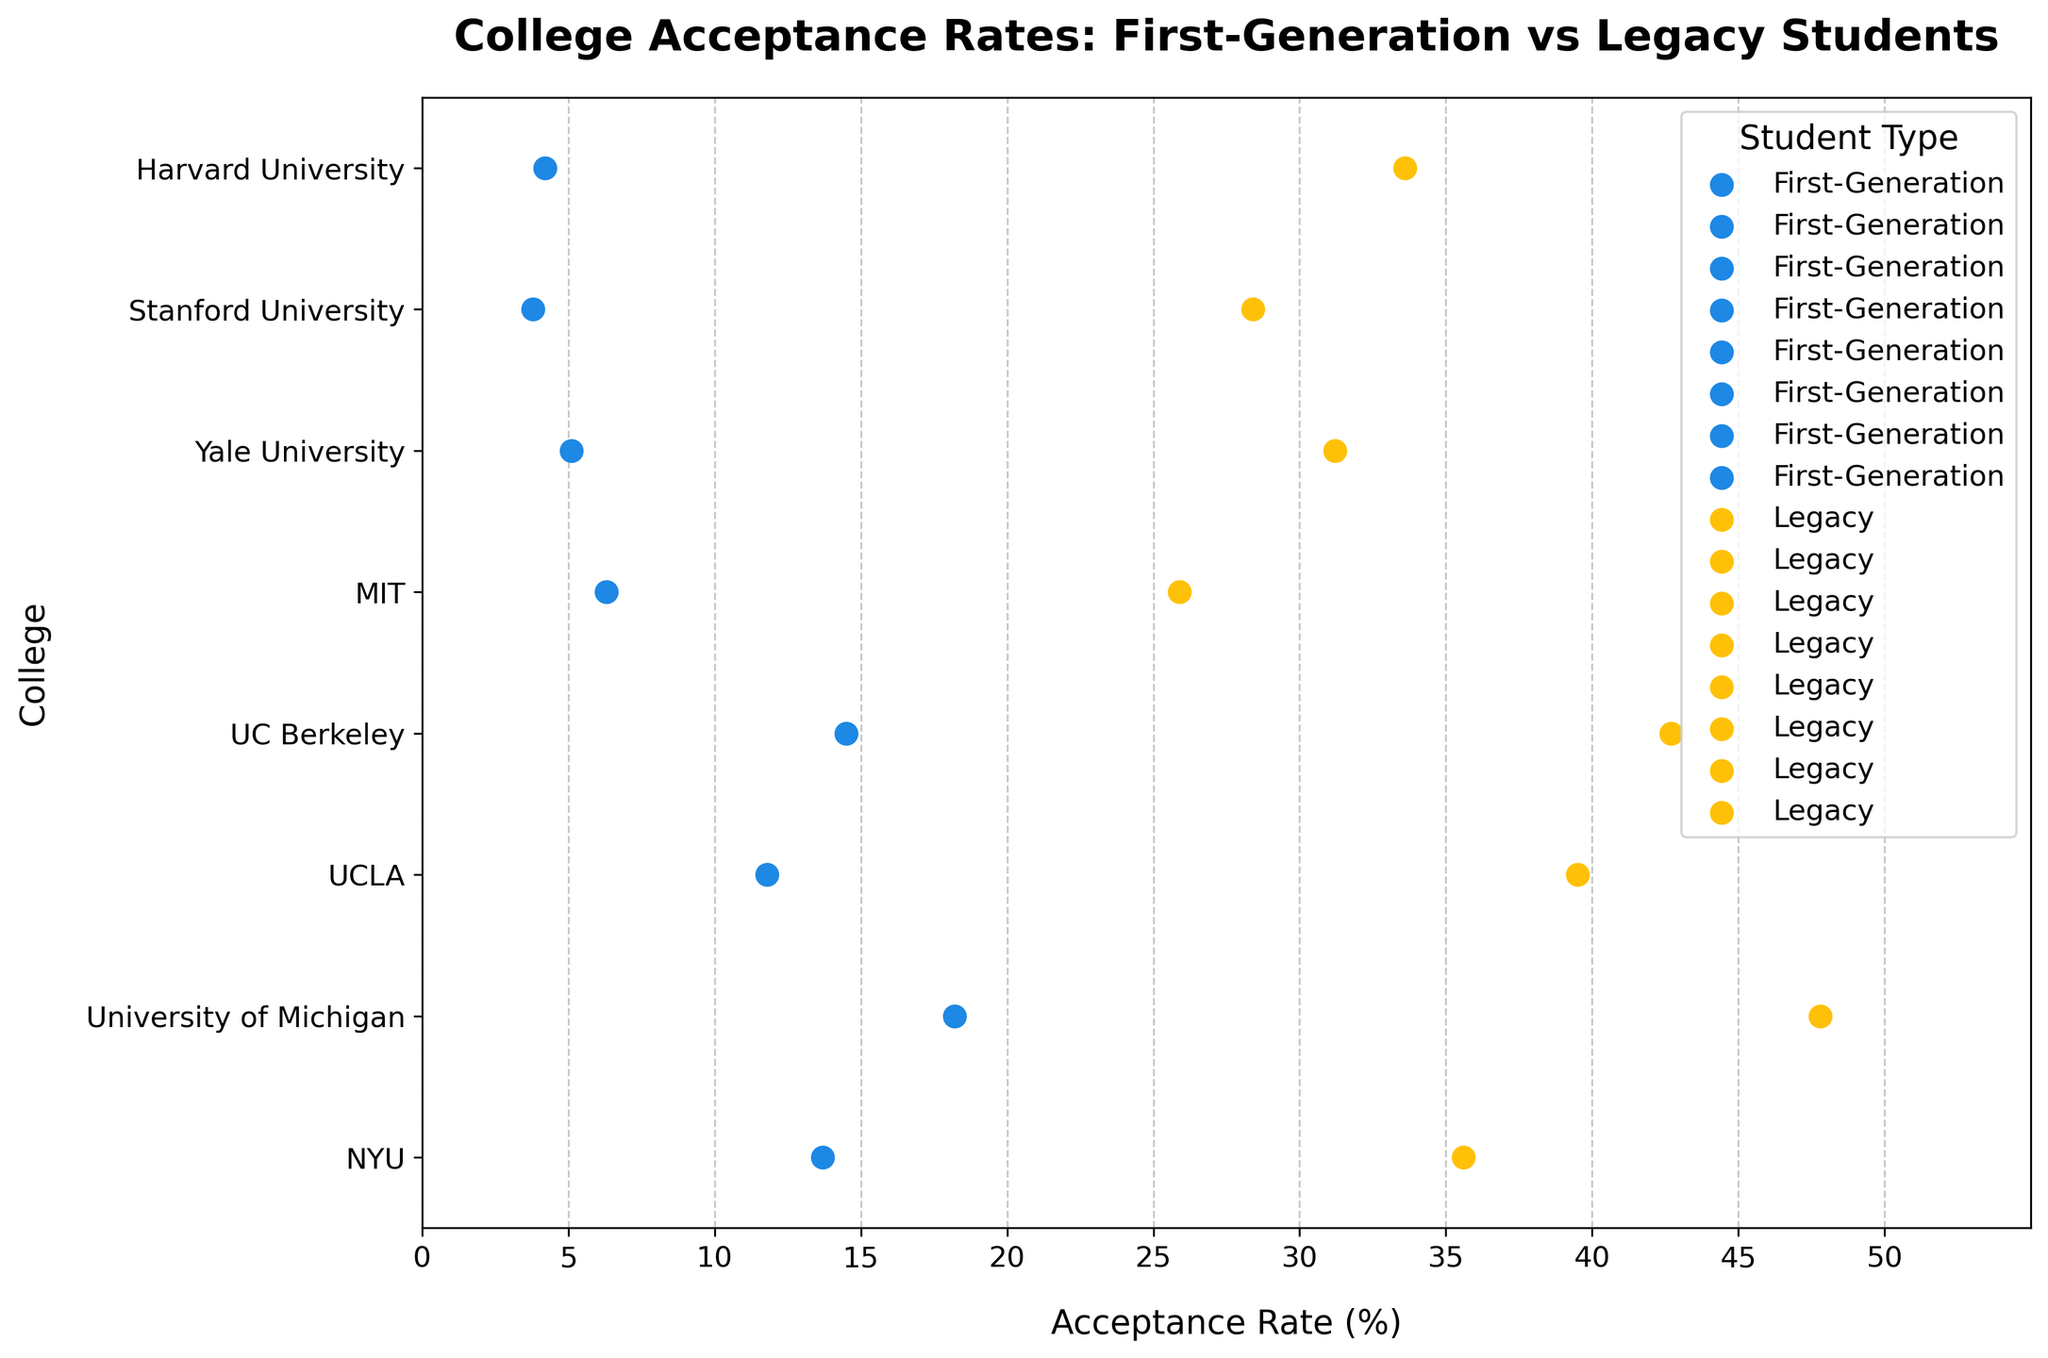What is the title of the figure? The title of the figure is located at the top and gives an overview of what the chart represents. From the given data and code, the title is "College Acceptance Rates: First-Generation vs Legacy Students."
Answer: College Acceptance Rates: First-Generation vs Legacy Students What is the acceptance rate for first-generation students at Stanford University? To find this, look for the blue dot (representing first-generation students) aligned with "Stanford University" on the y-axis. The corresponding x-axis value tells us the acceptance rate, which is 3.8.
Answer: 3.8% Which college has the highest acceptance rate for legacy students? To determine this, identify the yellow dot (representing legacy students) with the highest x-axis value. This dot is aligned with "University of Michigan" on the y-axis, corresponding to an acceptance rate of 47.8%.
Answer: University of Michigan What's the difference in acceptance rates between first-generation and legacy students at Harvard University? Identify the acceptance rates for Harvard University for both groups. First-generation students have an acceptance rate of 4.2%, and legacy students have an acceptance rate of 33.6%. The difference is 33.6 - 4.2 = 29.4%.
Answer: 29.4% Which student type generally has higher acceptance rates across the colleges? Compare the positions of the blue and yellow dots. Notice that the yellow dots (representing legacy students) are generally positioned to the right of the blue dots (representing first-generation students), indicating higher acceptance rates.
Answer: Legacy students What is the range of acceptance rates for first-generation students? To find the range, identify the lowest and highest x-axis values for the blue dots representing first-generation students. The lowest rate is 3.8% (Stanford University), and the highest is 18.2% (University of Michigan). So, the range is 18.2 - 3.8 = 14.4%.
Answer: 14.4% At which college is the difference in acceptance rates between first-generation and legacy students the smallest? Calculate the difference for each college and identify the smallest value. For example:
- Harvard University: 33.6 - 4.2 = 29.4
- Stanford University: 28.4 - 3.8 = 24.6
...
MIT has the smallest difference: 25.9 - 6.3 = 19.6.
Answer: MIT How many colleges have first-generation student acceptance rates below 10%? Identify the blue dots to the left of the 10% mark on the x-axis. The colleges are Harvard, Stanford, Yale, and MIT, a total of 4 colleges.
Answer: 4 Which college shows the highest acceptance rate for first-generation students? Among the blue dots, find the one with the highest x-axis value. This corresponds to "University of Michigan" with an acceptance rate of 18.2%.
Answer: University of Michigan 